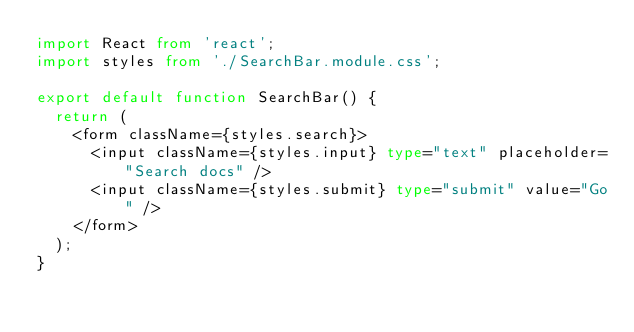Convert code to text. <code><loc_0><loc_0><loc_500><loc_500><_TypeScript_>import React from 'react';
import styles from './SearchBar.module.css';

export default function SearchBar() {
  return (
    <form className={styles.search}>
      <input className={styles.input} type="text" placeholder="Search docs" />
      <input className={styles.submit} type="submit" value="Go" />
    </form>
  );
}
</code> 